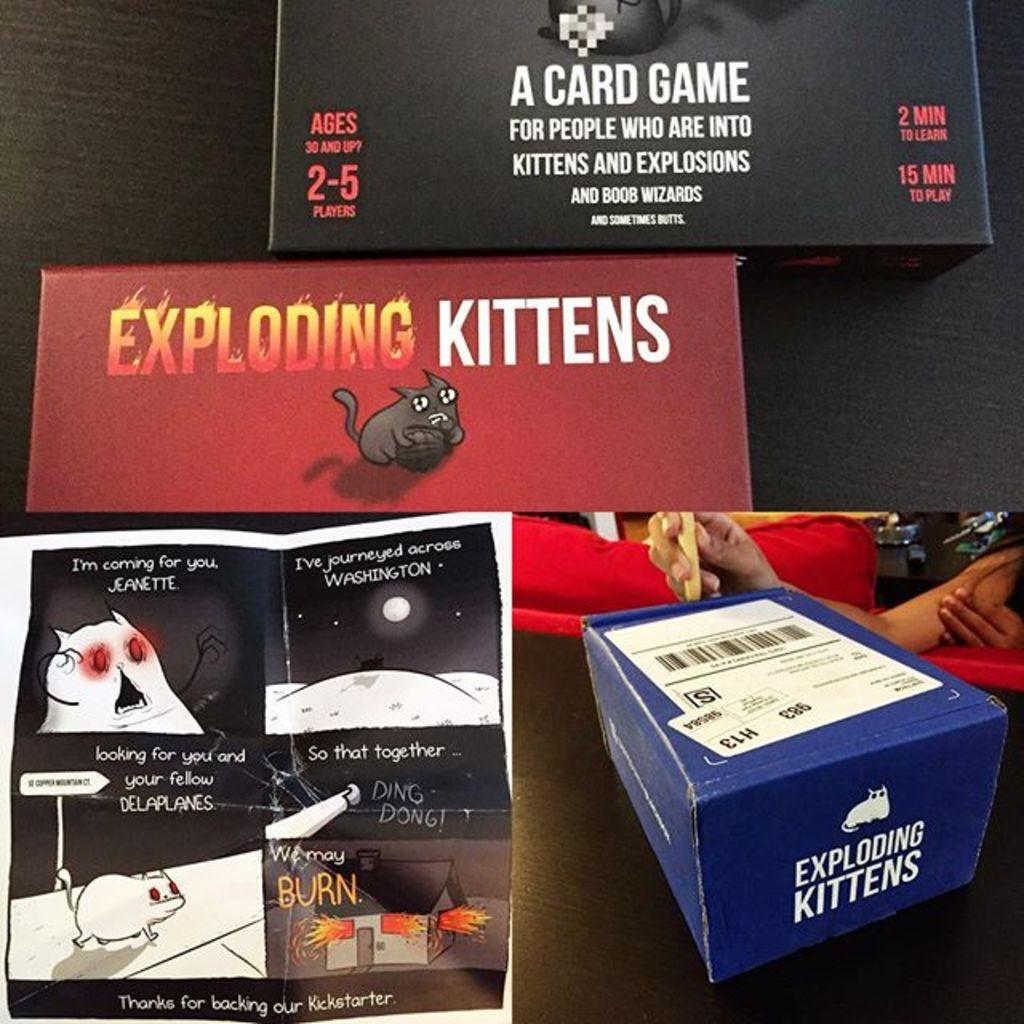<image>
Describe the image concisely. Three boxes for the card game Exploding Kittens. 